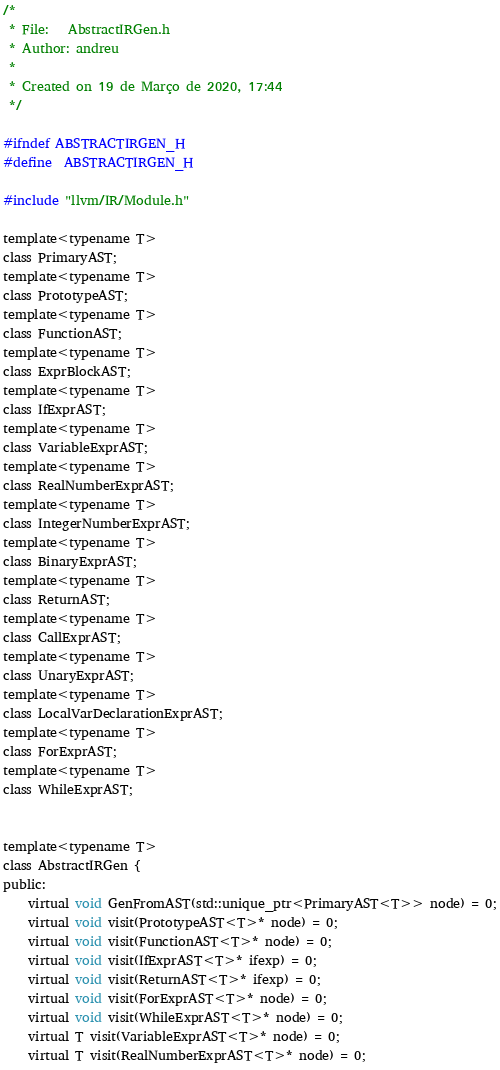<code> <loc_0><loc_0><loc_500><loc_500><_C_>/* 
 * File:   AbstractIRGen.h
 * Author: andreu
 *
 * Created on 19 de Março de 2020, 17:44
 */

#ifndef ABSTRACTIRGEN_H
#define	ABSTRACTIRGEN_H

#include "llvm/IR/Module.h"

template<typename T>
class PrimaryAST;
template<typename T>
class PrototypeAST;
template<typename T>
class FunctionAST;
template<typename T>
class ExprBlockAST;
template<typename T>
class IfExprAST;
template<typename T>
class VariableExprAST;
template<typename T>
class RealNumberExprAST;
template<typename T>
class IntegerNumberExprAST;
template<typename T>
class BinaryExprAST;
template<typename T>
class ReturnAST;
template<typename T>
class CallExprAST;
template<typename T>
class UnaryExprAST;
template<typename T>
class LocalVarDeclarationExprAST;
template<typename T>
class ForExprAST;
template<typename T>
class WhileExprAST;


template<typename T>
class AbstractIRGen {
public:
    virtual void GenFromAST(std::unique_ptr<PrimaryAST<T>> node) = 0;
    virtual void visit(PrototypeAST<T>* node) = 0;
    virtual void visit(FunctionAST<T>* node) = 0;
    virtual void visit(IfExprAST<T>* ifexp) = 0;
    virtual void visit(ReturnAST<T>* ifexp) = 0;
    virtual void visit(ForExprAST<T>* node) = 0;
    virtual void visit(WhileExprAST<T>* node) = 0;
    virtual T visit(VariableExprAST<T>* node) = 0;
    virtual T visit(RealNumberExprAST<T>* node) = 0;</code> 